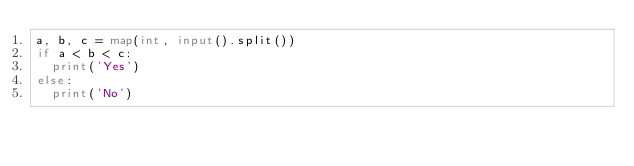Convert code to text. <code><loc_0><loc_0><loc_500><loc_500><_Python_>a, b, c = map(int, input().split())
if a < b < c:
	print('Yes')
else:
	print('No')
</code> 